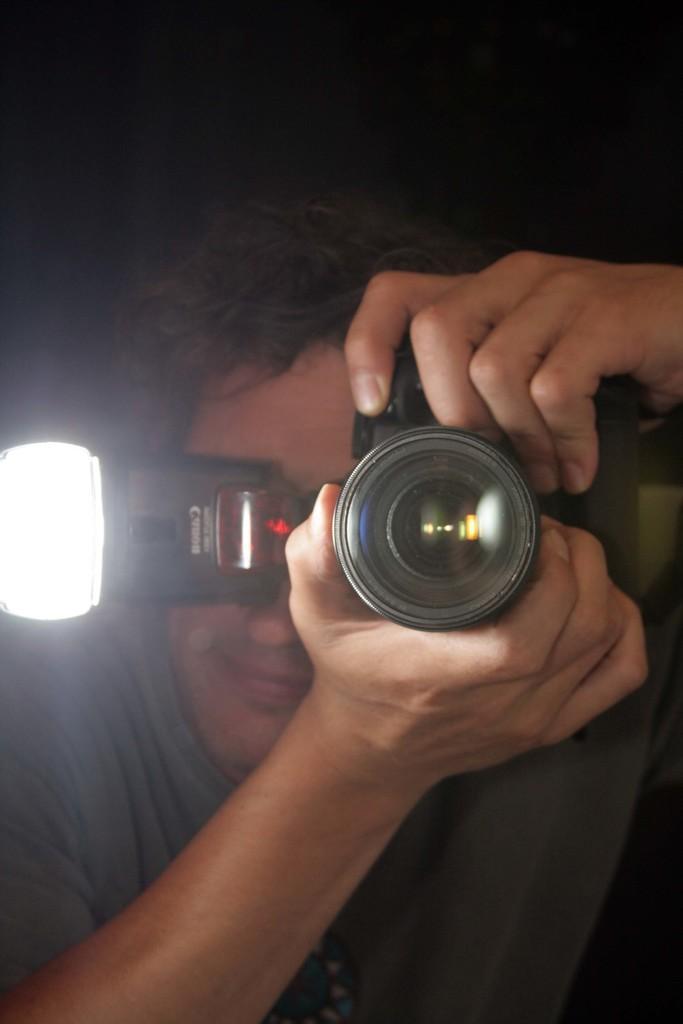In one or two sentences, can you explain what this image depicts? In this image we can see a person holding a camera and clicking picture. 